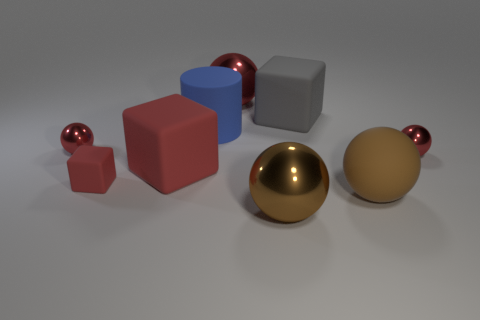There is a brown sphere behind the brown metallic sphere; what is its size?
Provide a short and direct response. Large. There is a sphere that is behind the large cylinder behind the big rubber ball; how big is it?
Your answer should be very brief. Large. Are there more big red matte objects than tiny yellow matte cubes?
Ensure brevity in your answer.  Yes. Is the number of small shiny balls behind the big brown metallic sphere greater than the number of matte cubes that are right of the gray matte object?
Offer a very short reply. Yes. What size is the ball that is in front of the big red rubber object and to the right of the large gray rubber object?
Your answer should be very brief. Large. How many objects are the same size as the gray block?
Make the answer very short. 5. There is a big block that is the same color as the tiny matte object; what is its material?
Offer a very short reply. Rubber. There is a shiny thing that is left of the rubber cylinder; does it have the same shape as the big brown rubber thing?
Provide a short and direct response. Yes. Is the number of big rubber balls that are on the left side of the small red rubber cube less than the number of tiny blue cylinders?
Ensure brevity in your answer.  No. Are there any big metallic spheres that have the same color as the big rubber ball?
Your response must be concise. Yes. 